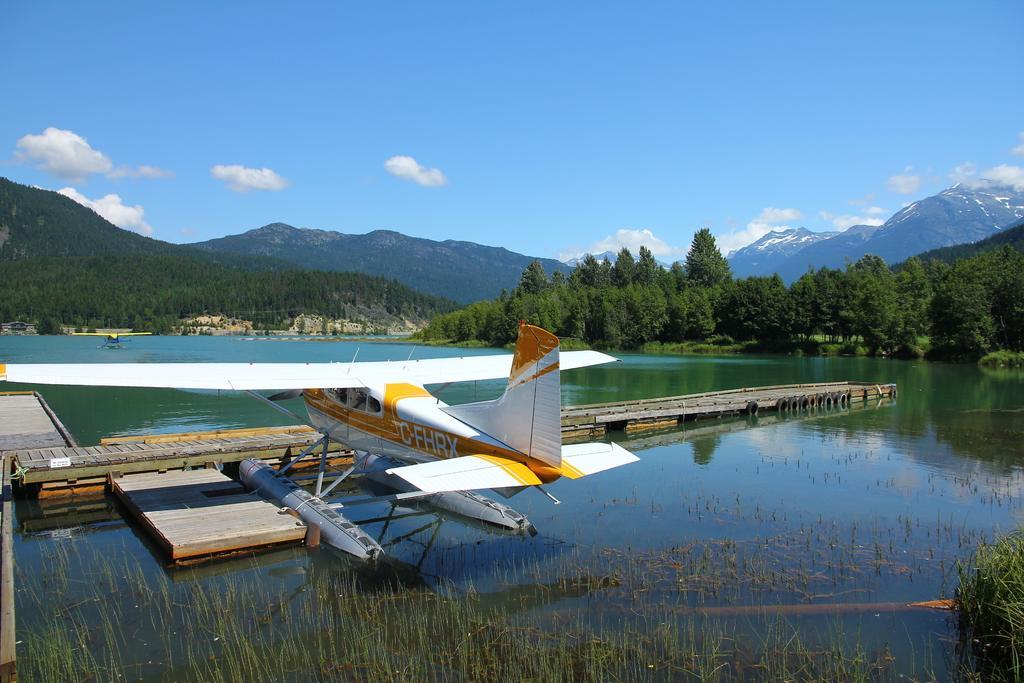Describe this image in one or two sentences. In this image I can see a white color seaplane on the water. At the bottom of the image I can see the grass in the water. In the background there are some trees and hills. On the top of the image I can see the sky and clouds. 